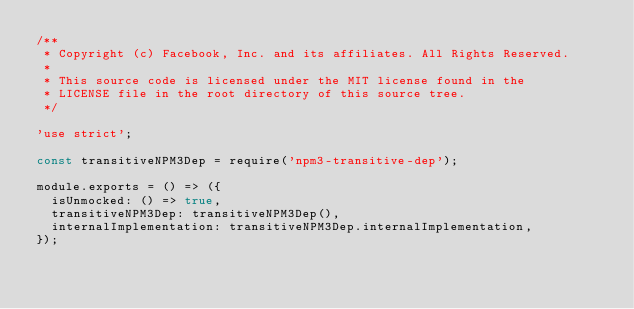<code> <loc_0><loc_0><loc_500><loc_500><_JavaScript_>/**
 * Copyright (c) Facebook, Inc. and its affiliates. All Rights Reserved.
 *
 * This source code is licensed under the MIT license found in the
 * LICENSE file in the root directory of this source tree.
 */

'use strict';

const transitiveNPM3Dep = require('npm3-transitive-dep');

module.exports = () => ({
  isUnmocked: () => true,
  transitiveNPM3Dep: transitiveNPM3Dep(),
  internalImplementation: transitiveNPM3Dep.internalImplementation,
});
</code> 